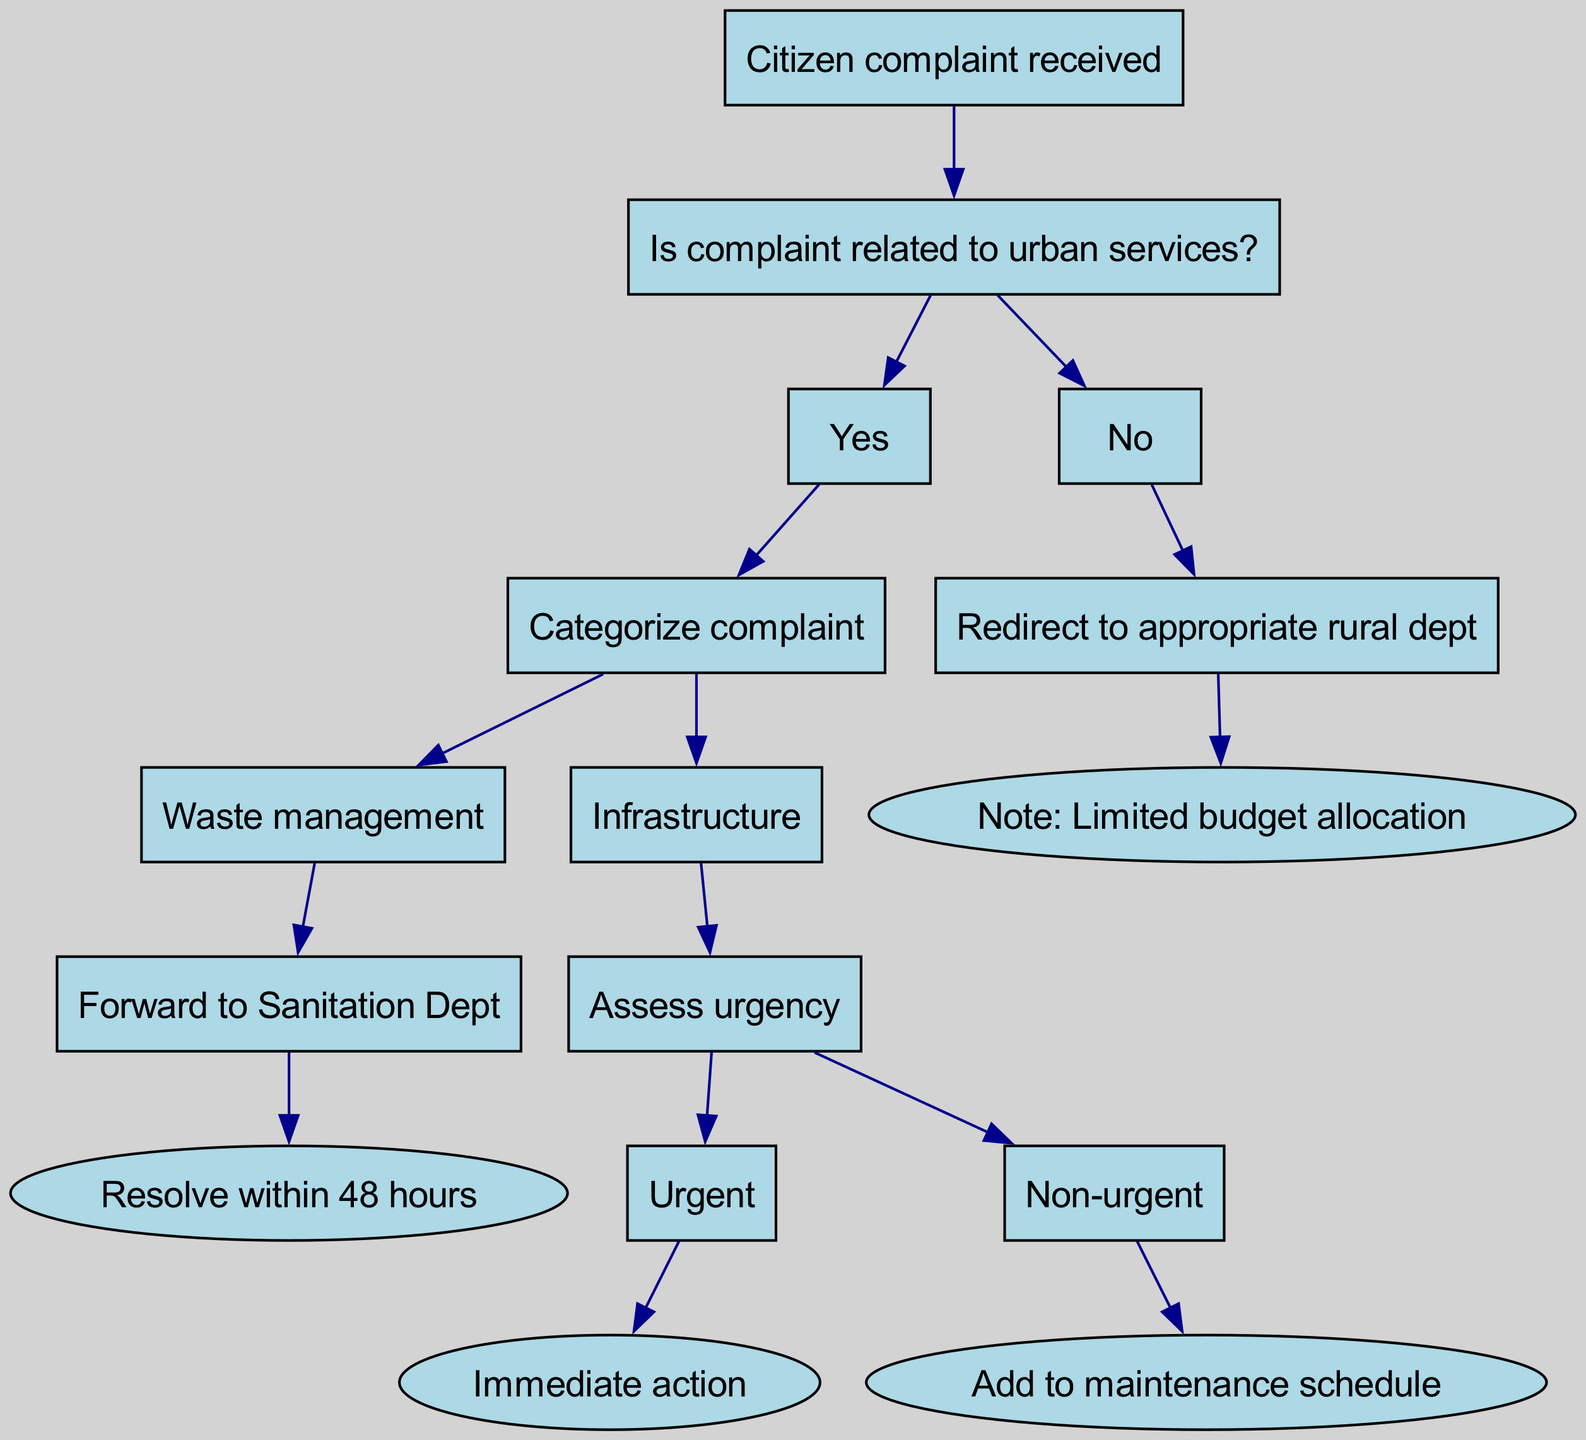What is the first step after a citizen complaint is received? The diagram indicates that the first step after receiving a citizen complaint is to determine if the complaint is related to urban services. This is the initial decision node that guides the subsequent actions.
Answer: Is complaint related to urban services? How many children nodes does the "Is complaint related to urban services?" node have? The node "Is complaint related to urban services?" has two children nodes: one for "Yes" and one for "No." This indicates the two primary possible pathways from this decision point.
Answer: 2 What action is taken for "Waste management" complaints? According to the diagram, if a complaint is categorized as "Waste management," it is forwarded to the Sanitation Department for resolution. This indicates a specific action tied to that type of complaint.
Answer: Forward to Sanitation Dept What happens if the complaint is categorized under "Infrastructure" and marked urgent? If the complaint is categorized under "Infrastructure" and assessed as urgent, immediate action is required according to the diagram. This shows the prioritized response based on urgency.
Answer: Immediate action If a complaint is not related to urban services, what is the next step? For complaints not related to urban services, the diagram indicates that the complaint will be redirected to the appropriate rural department. This step ensures that rural-related issues are handled correctly.
Answer: Redirect to appropriate rural dept What color indicates the node for "Non-urgent" issues? The node representing "Non-urgent" is colored light green as depicted in the diagram. This color-coding helps differentiate between the urgency of issues at a glance.
Answer: Light green What does the note under "Redirect to appropriate rural dept" indicate? The note states "Limited budget allocation," which highlights a constraint that may affect how rural complaints are handled. It serves as an important consideration for managing expectations regarding resources.
Answer: Limited budget allocation What are the two possible outcomes for the "Assess urgency" decision in the "Infrastructure" category? The outcomes for assessing urgency in the "Infrastructure" category are "Urgent" leading to "Immediate action" and "Non-urgent" leading to "Add to maintenance schedule." These outcomes reflect the varying levels of urgency and response required.
Answer: Urgent and Non-urgent How many total distinct types of complaints are categorized in the decision tree? There are two distinct types of complaints categorized in the decision tree: "Waste management" and "Infrastructure." This demonstrates that the decision-making process has a limited scope of issues addressed.
Answer: 2 